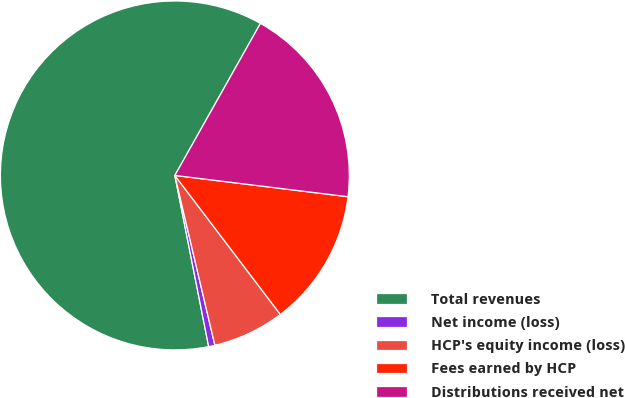Convert chart. <chart><loc_0><loc_0><loc_500><loc_500><pie_chart><fcel>Total revenues<fcel>Net income (loss)<fcel>HCP's equity income (loss)<fcel>Fees earned by HCP<fcel>Distributions received net<nl><fcel>61.27%<fcel>0.58%<fcel>6.65%<fcel>12.72%<fcel>18.79%<nl></chart> 